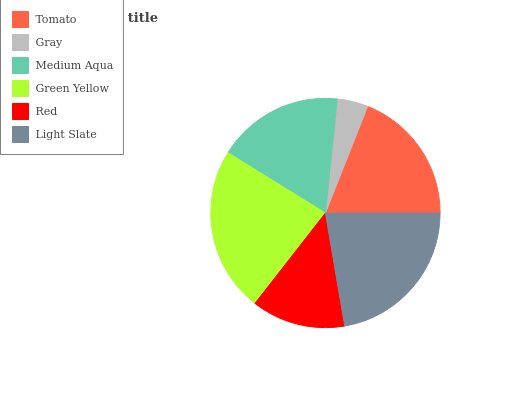Is Gray the minimum?
Answer yes or no. Yes. Is Green Yellow the maximum?
Answer yes or no. Yes. Is Medium Aqua the minimum?
Answer yes or no. No. Is Medium Aqua the maximum?
Answer yes or no. No. Is Medium Aqua greater than Gray?
Answer yes or no. Yes. Is Gray less than Medium Aqua?
Answer yes or no. Yes. Is Gray greater than Medium Aqua?
Answer yes or no. No. Is Medium Aqua less than Gray?
Answer yes or no. No. Is Tomato the high median?
Answer yes or no. Yes. Is Medium Aqua the low median?
Answer yes or no. Yes. Is Green Yellow the high median?
Answer yes or no. No. Is Green Yellow the low median?
Answer yes or no. No. 